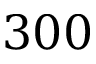<formula> <loc_0><loc_0><loc_500><loc_500>3 0 0</formula> 